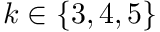<formula> <loc_0><loc_0><loc_500><loc_500>k \in \{ 3 , 4 , 5 \}</formula> 